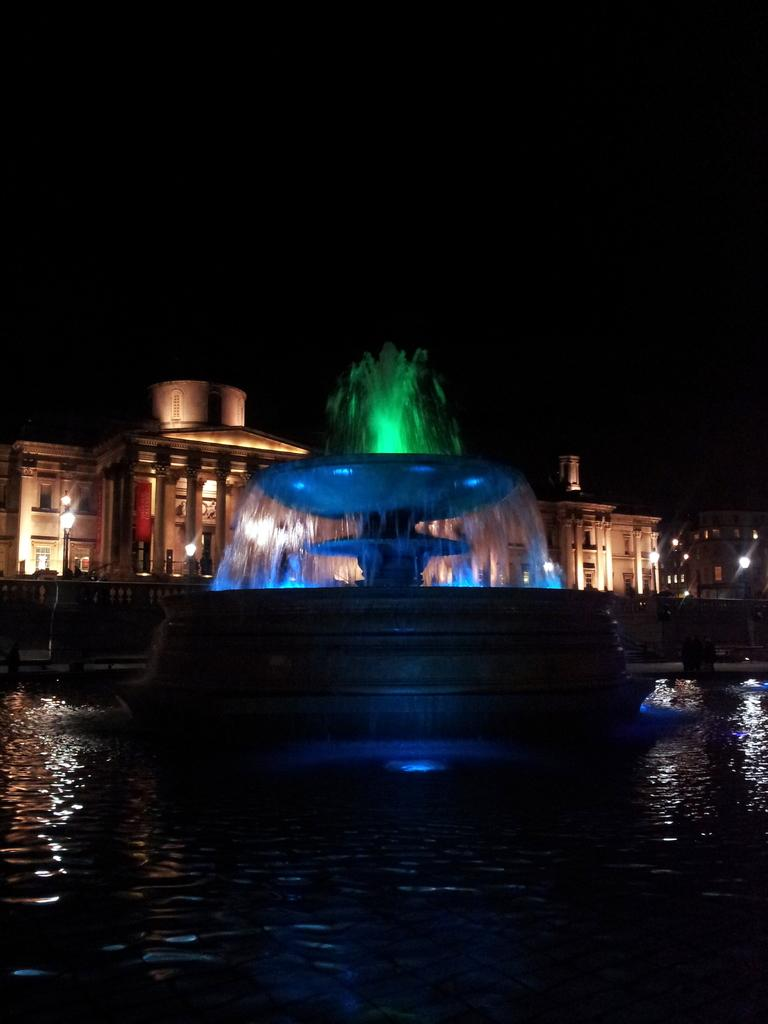What is the main feature in the water in the image? There is a fountain in the water in the image. What can be seen behind the fountain? There are buildings behind the fountain. What type of structures are present in the image? Street light poles are present in the image. How would you describe the lighting in the top part of the image? The top part of the image appears to be dark. What type of dirt can be seen on the faucet in the image? There is no faucet present in the image, as it features a fountain in the water. 